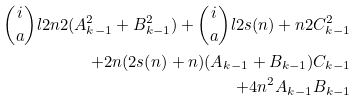<formula> <loc_0><loc_0><loc_500><loc_500>\binom { i } { a } l { 2 n } { 2 } ( A _ { k - 1 } ^ { 2 } + B _ { k - 1 } ^ { 2 } ) + \binom { i } { a } l { 2 s ( n ) + n } { 2 } C _ { k - 1 } ^ { 2 } \\ + 2 n ( 2 s ( n ) + n ) ( A _ { k - 1 } + B _ { k - 1 } ) C _ { k - 1 } \\ + 4 n ^ { 2 } A _ { k - 1 } B _ { k - 1 }</formula> 